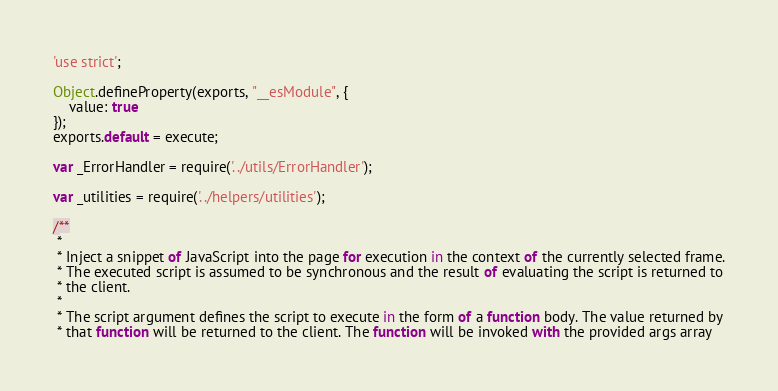Convert code to text. <code><loc_0><loc_0><loc_500><loc_500><_JavaScript_>'use strict';

Object.defineProperty(exports, "__esModule", {
    value: true
});
exports.default = execute;

var _ErrorHandler = require('../utils/ErrorHandler');

var _utilities = require('../helpers/utilities');

/**
 *
 * Inject a snippet of JavaScript into the page for execution in the context of the currently selected frame.
 * The executed script is assumed to be synchronous and the result of evaluating the script is returned to
 * the client.
 *
 * The script argument defines the script to execute in the form of a function body. The value returned by
 * that function will be returned to the client. The function will be invoked with the provided args array</code> 